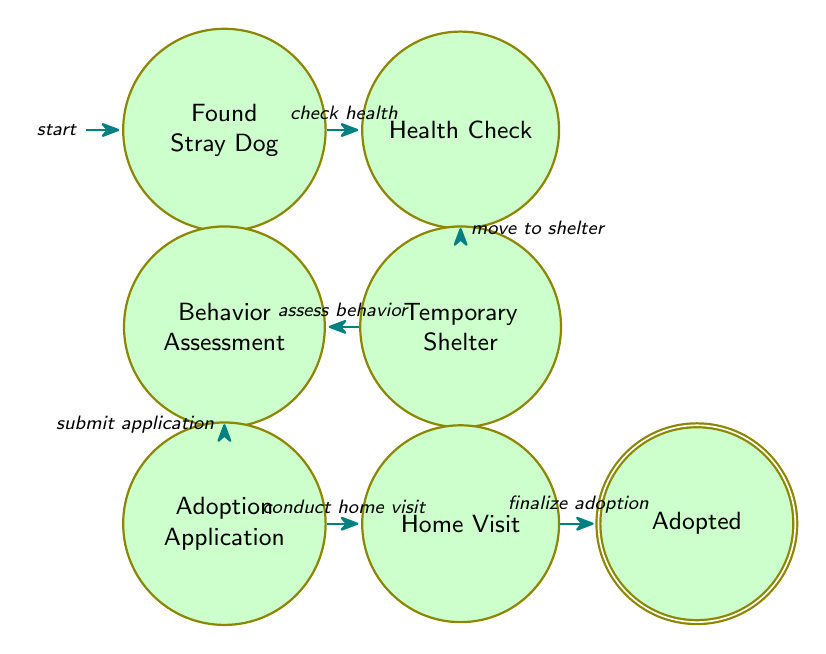What is the first state in the adoption procedure? The first state in the diagram is labeled "Found Stray Dog," which indicates the beginning of the adoption procedure.
Answer: Found Stray Dog How many total states are there in this finite state machine diagram? By counting the states in the diagram, there are a total of six distinct states listed: Found Stray Dog, Health Check, Temporary Shelter, Behavior Assessment, Adoption Application, Home Visit, and Adopted.
Answer: 7 What is the last state in the adoption procedure? The last state in the diagram is labeled "Adopted," meaning it is the final outcome of the adoption process.
Answer: Adopted Which two states does the "submit application" transition occur between? The "submit application" transition indicates a move from "Behavior Assessment" to "Adoption Application," following the evaluation of the dog's behavior.
Answer: Behavior Assessment and Adoption Application What action occurs after the Health Check state? After the Health Check state, the transition labeled "move to shelter" occurs, indicating that the dog is placed in a temporary shelter.
Answer: Temporary Shelter What is the relationship of the Home Visit state to the Adoption Application state? The Home Visit state is directly connected to the Adoption Application state through the transition labeled "conduct home visit," indicating a sequence in the adoption process.
Answer: Home Visit follows Adoption Application Which transition leads to the final state of Adopted? The transition that leads to the final state of Adopted is labeled "finalize adoption," which stems from the Home Visit state as the last step in the process.
Answer: finalize adoption 